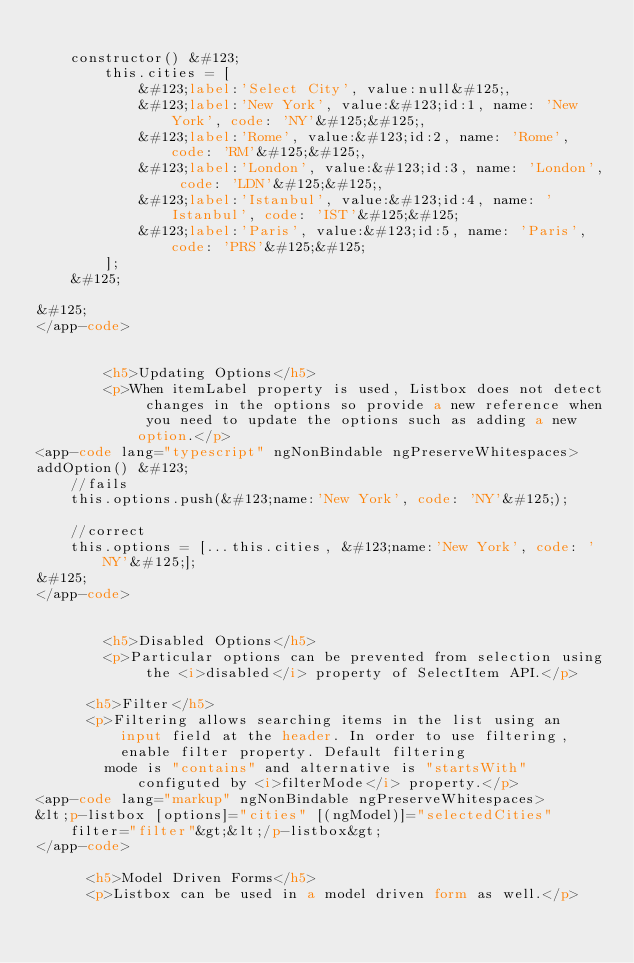Convert code to text. <code><loc_0><loc_0><loc_500><loc_500><_HTML_>
    constructor() &#123;
        this.cities = [
            &#123;label:'Select City', value:null&#125;,
            &#123;label:'New York', value:&#123;id:1, name: 'New York', code: 'NY'&#125;&#125;,
            &#123;label:'Rome', value:&#123;id:2, name: 'Rome', code: 'RM'&#125;&#125;,
            &#123;label:'London', value:&#123;id:3, name: 'London', code: 'LDN'&#125;&#125;,
            &#123;label:'Istanbul', value:&#123;id:4, name: 'Istanbul', code: 'IST'&#125;&#125;
            &#123;label:'Paris', value:&#123;id:5, name: 'Paris', code: 'PRS'&#125;&#125;
        ];
    &#125;

&#125;
</app-code>


        <h5>Updating Options</h5>
        <p>When itemLabel property is used, Listbox does not detect changes in the options so provide a new reference when you need to update the options such as adding a new option.</p>
<app-code lang="typescript" ngNonBindable ngPreserveWhitespaces>
addOption() &#123;
    //fails
    this.options.push(&#123;name:'New York', code: 'NY'&#125;);

    //correct
    this.options = [...this.cities, &#123;name:'New York', code: 'NY'&#125;];
&#125;
</app-code>


        <h5>Disabled Options</h5>
        <p>Particular options can be prevented from selection using the <i>disabled</i> property of SelectItem API.</p>

      <h5>Filter</h5>
      <p>Filtering allows searching items in the list using an input field at the header. In order to use filtering, enable filter property. Default filtering
        mode is "contains" and alternative is "startsWith" configuted by <i>filterMode</i> property.</p>
<app-code lang="markup" ngNonBindable ngPreserveWhitespaces>
&lt;p-listbox [options]="cities" [(ngModel)]="selectedCities" filter="filter"&gt;&lt;/p-listbox&gt;
</app-code>

      <h5>Model Driven Forms</h5>
      <p>Listbox can be used in a model driven form as well.</p></code> 